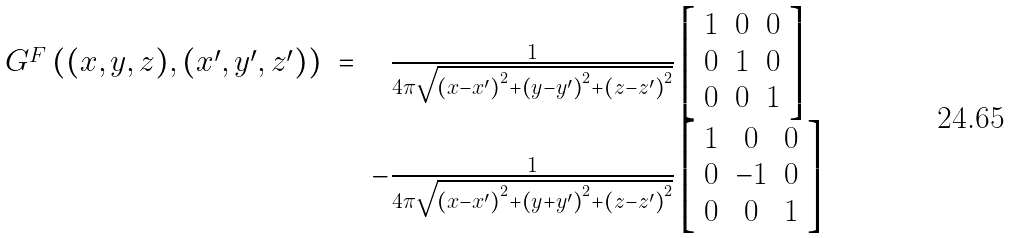Convert formula to latex. <formula><loc_0><loc_0><loc_500><loc_500>\begin{array} { c c c } G ^ { F } \left ( ( x , y , z ) , ( x ^ { \prime } , y ^ { \prime } , z ^ { \prime } ) \right ) & = & \frac { 1 } { 4 \pi \sqrt { \left ( x - x ^ { \prime } \right ) ^ { 2 } + \left ( y - y ^ { \prime } \right ) ^ { 2 } + \left ( z - z ^ { \prime } \right ) ^ { 2 } } } \left [ \begin{array} { c c c } 1 & 0 & 0 \\ 0 & 1 & 0 \\ 0 & 0 & 1 \end{array} \right ] \\ & & - \frac { 1 } { 4 \pi \sqrt { \left ( x - x ^ { \prime } \right ) ^ { 2 } + \left ( y + y ^ { \prime } \right ) ^ { 2 } + \left ( z - z ^ { \prime } \right ) ^ { 2 } } } \left [ \begin{array} { c c c } 1 & 0 & 0 \\ 0 & - 1 & 0 \\ 0 & 0 & 1 \end{array} \right ] \end{array}</formula> 